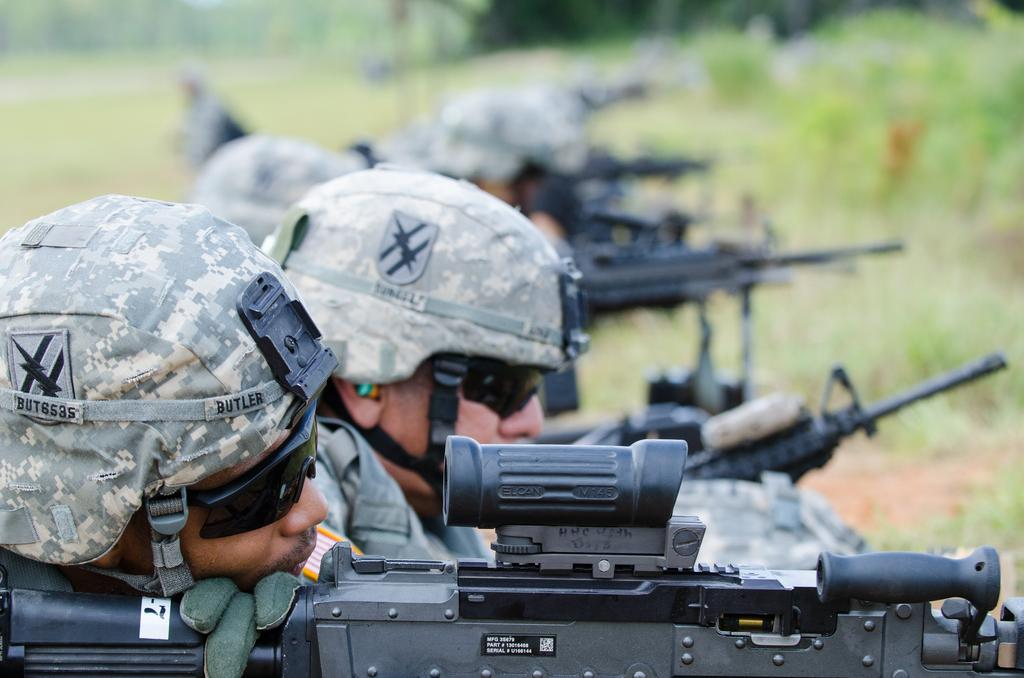What are the people on the left side of the image wearing? The people are wearing uniforms. What type of headgear are the people wearing? The people are wearing caps. What type of eyewear are the people wearing? The people are wearing glasses. What are the people holding in their hands? The people are holding guns. What can be seen in the background of the image? There are plants and trees in the background of the image. What type of bread can be seen in the image? There is no bread present in the image. What type of station is visible in the image? There is no station present in the image. 